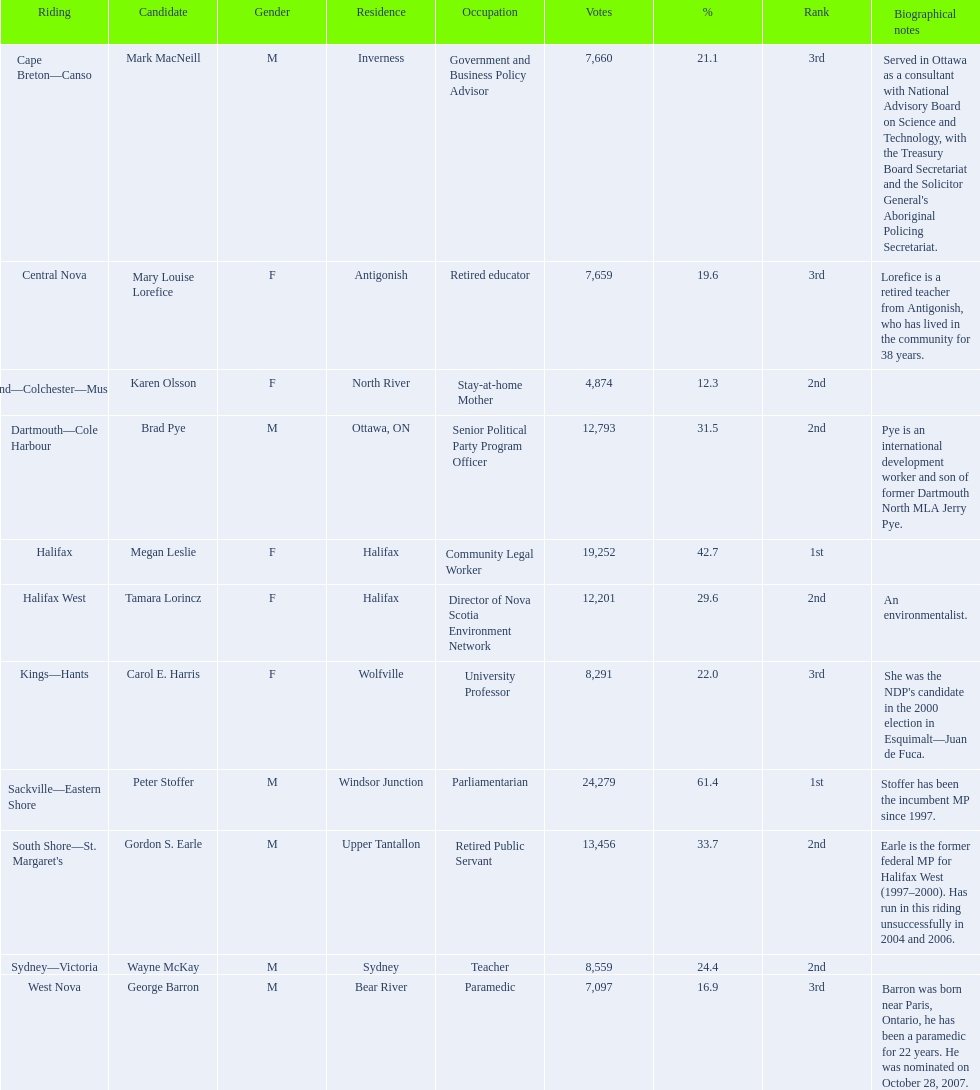How many nominees garnered more votes than tamara lorincz? 4. 